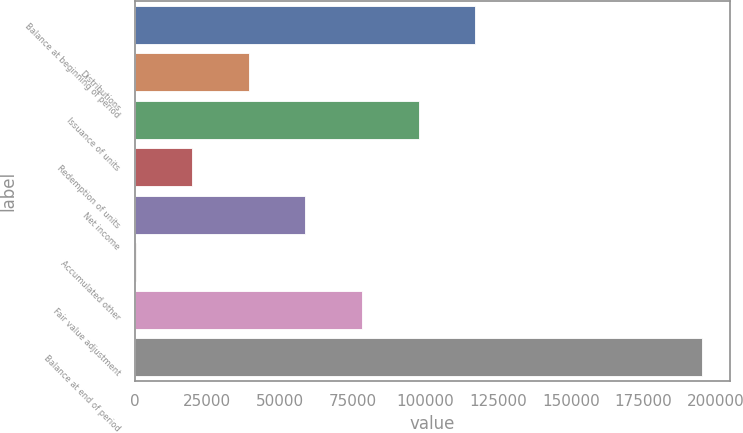<chart> <loc_0><loc_0><loc_500><loc_500><bar_chart><fcel>Balance at beginning of period<fcel>Distributions<fcel>Issuance of units<fcel>Redemption of units<fcel>Net income<fcel>Accumulated other<fcel>Fair value adjustment<fcel>Balance at end of period<nl><fcel>117134<fcel>39238.8<fcel>97660.5<fcel>19764.9<fcel>58712.7<fcel>291<fcel>78186.6<fcel>195030<nl></chart> 